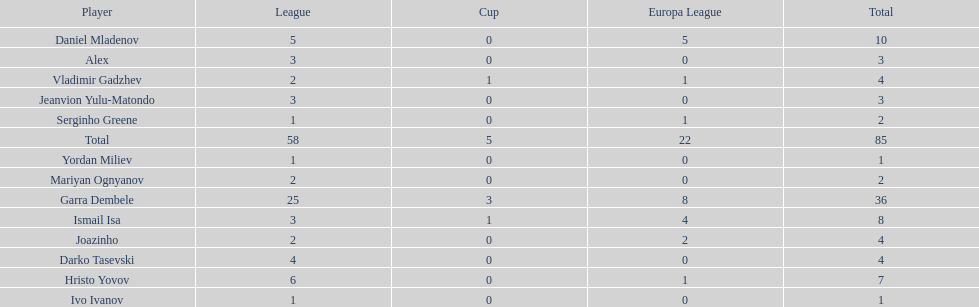What is the total number of goals scored by ismail isa in the current season? 8. 